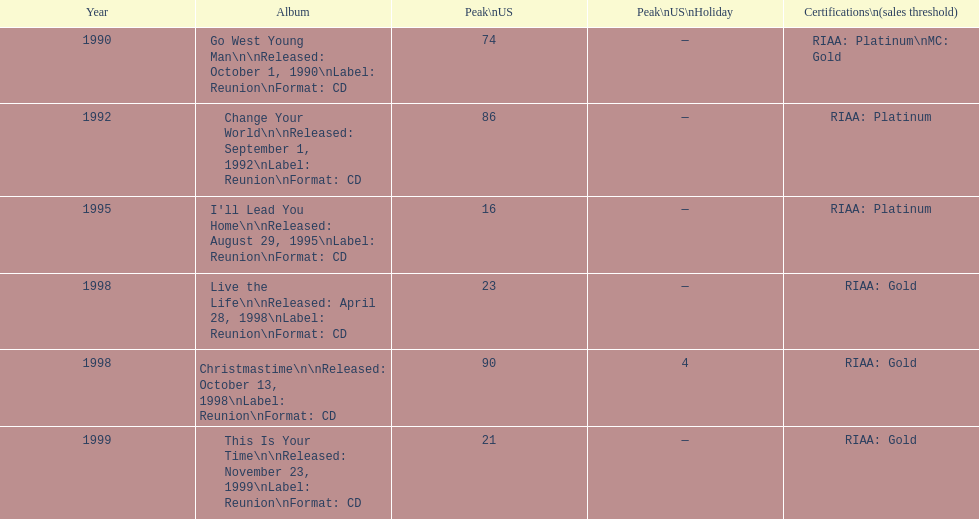What was the first michael w smith album? Go West Young Man. 